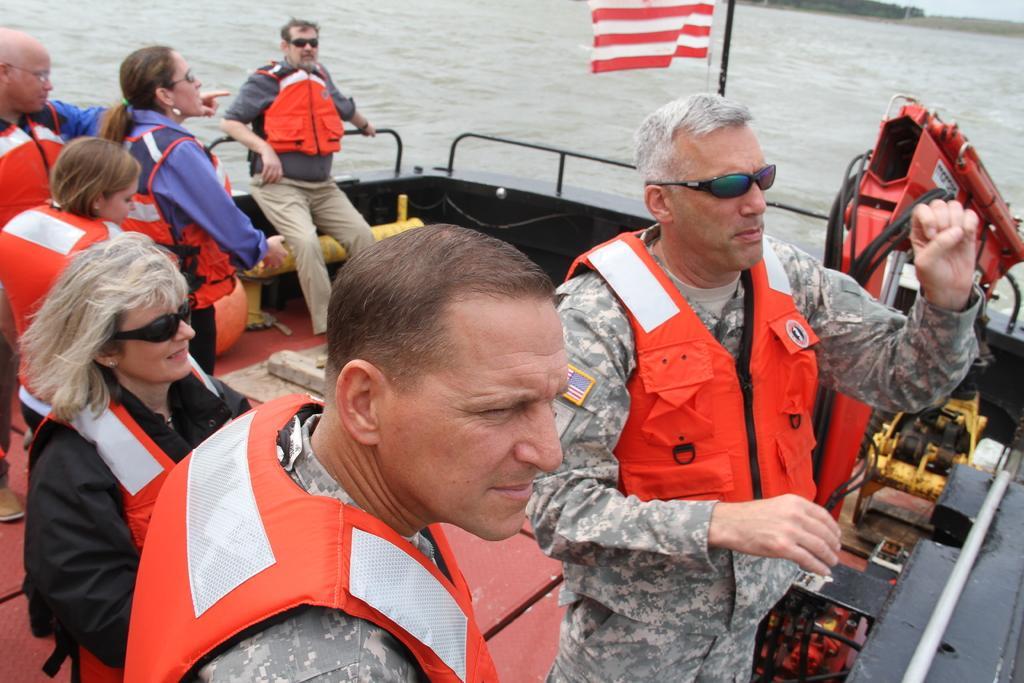Describe this image in one or two sentences. In this image we can see a group of persons are standing, in the boat, they are wearing the safety jacket, there is the water, there are trees. 